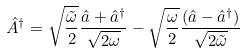<formula> <loc_0><loc_0><loc_500><loc_500>\hat { A } ^ { \dagger } = \sqrt { \frac { \tilde { \omega } } { 2 } } \frac { \hat { a } + \hat { a } ^ { \dagger } } { \sqrt { 2 \omega } } - \sqrt { \frac { \omega } { 2 } } \frac { ( \hat { a } - \hat { a } ^ { \dagger } ) } { \sqrt { 2 \tilde { \omega } } }</formula> 